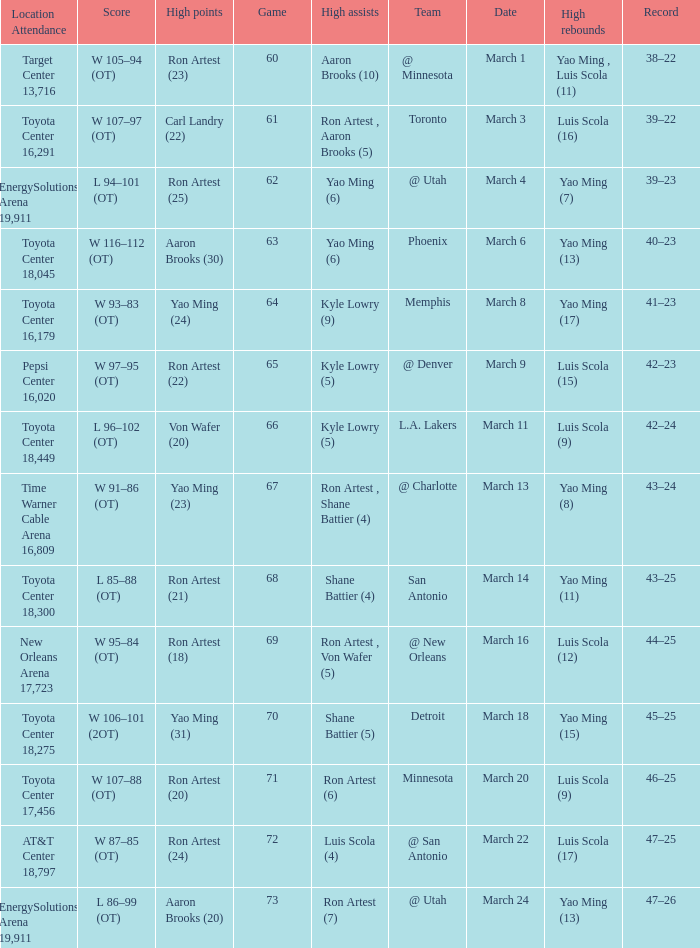Who had the most poinst in game 72? Ron Artest (24). Could you parse the entire table? {'header': ['Location Attendance', 'Score', 'High points', 'Game', 'High assists', 'Team', 'Date', 'High rebounds', 'Record'], 'rows': [['Target Center 13,716', 'W 105–94 (OT)', 'Ron Artest (23)', '60', 'Aaron Brooks (10)', '@ Minnesota', 'March 1', 'Yao Ming , Luis Scola (11)', '38–22'], ['Toyota Center 16,291', 'W 107–97 (OT)', 'Carl Landry (22)', '61', 'Ron Artest , Aaron Brooks (5)', 'Toronto', 'March 3', 'Luis Scola (16)', '39–22'], ['EnergySolutions Arena 19,911', 'L 94–101 (OT)', 'Ron Artest (25)', '62', 'Yao Ming (6)', '@ Utah', 'March 4', 'Yao Ming (7)', '39–23'], ['Toyota Center 18,045', 'W 116–112 (OT)', 'Aaron Brooks (30)', '63', 'Yao Ming (6)', 'Phoenix', 'March 6', 'Yao Ming (13)', '40–23'], ['Toyota Center 16,179', 'W 93–83 (OT)', 'Yao Ming (24)', '64', 'Kyle Lowry (9)', 'Memphis', 'March 8', 'Yao Ming (17)', '41–23'], ['Pepsi Center 16,020', 'W 97–95 (OT)', 'Ron Artest (22)', '65', 'Kyle Lowry (5)', '@ Denver', 'March 9', 'Luis Scola (15)', '42–23'], ['Toyota Center 18,449', 'L 96–102 (OT)', 'Von Wafer (20)', '66', 'Kyle Lowry (5)', 'L.A. Lakers', 'March 11', 'Luis Scola (9)', '42–24'], ['Time Warner Cable Arena 16,809', 'W 91–86 (OT)', 'Yao Ming (23)', '67', 'Ron Artest , Shane Battier (4)', '@ Charlotte', 'March 13', 'Yao Ming (8)', '43–24'], ['Toyota Center 18,300', 'L 85–88 (OT)', 'Ron Artest (21)', '68', 'Shane Battier (4)', 'San Antonio', 'March 14', 'Yao Ming (11)', '43–25'], ['New Orleans Arena 17,723', 'W 95–84 (OT)', 'Ron Artest (18)', '69', 'Ron Artest , Von Wafer (5)', '@ New Orleans', 'March 16', 'Luis Scola (12)', '44–25'], ['Toyota Center 18,275', 'W 106–101 (2OT)', 'Yao Ming (31)', '70', 'Shane Battier (5)', 'Detroit', 'March 18', 'Yao Ming (15)', '45–25'], ['Toyota Center 17,456', 'W 107–88 (OT)', 'Ron Artest (20)', '71', 'Ron Artest (6)', 'Minnesota', 'March 20', 'Luis Scola (9)', '46–25'], ['AT&T Center 18,797', 'W 87–85 (OT)', 'Ron Artest (24)', '72', 'Luis Scola (4)', '@ San Antonio', 'March 22', 'Luis Scola (17)', '47–25'], ['EnergySolutions Arena 19,911', 'L 86–99 (OT)', 'Aaron Brooks (20)', '73', 'Ron Artest (7)', '@ Utah', 'March 24', 'Yao Ming (13)', '47–26']]} 